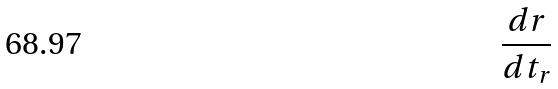<formula> <loc_0><loc_0><loc_500><loc_500>\frac { d r } { d t _ { r } }</formula> 